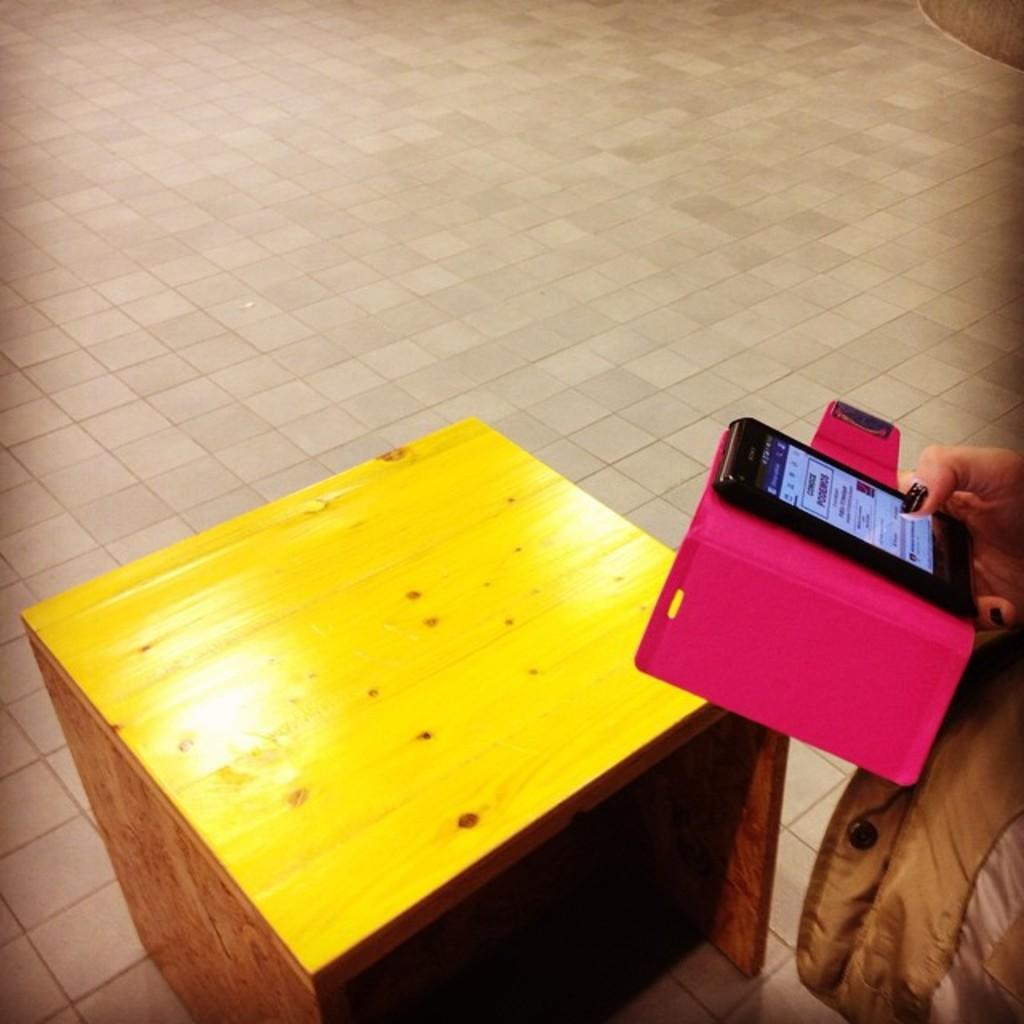What is the color and material of the table in the image? The table in the image is a yellow color wooden table. What is the color and material of the floor in the image? The floor in the image is also yellow color wooden. What is the human hand holding in the image? A human hand is holding a mobile phone in the image. Can you describe the cloth visible in the image? There is a cloth visible in the image, but its specific characteristics are not mentioned in the provided facts. How many fans are visible in the image? There are no fans present in the image. What type of trucks can be seen in the image? There are no trucks present in the image. 